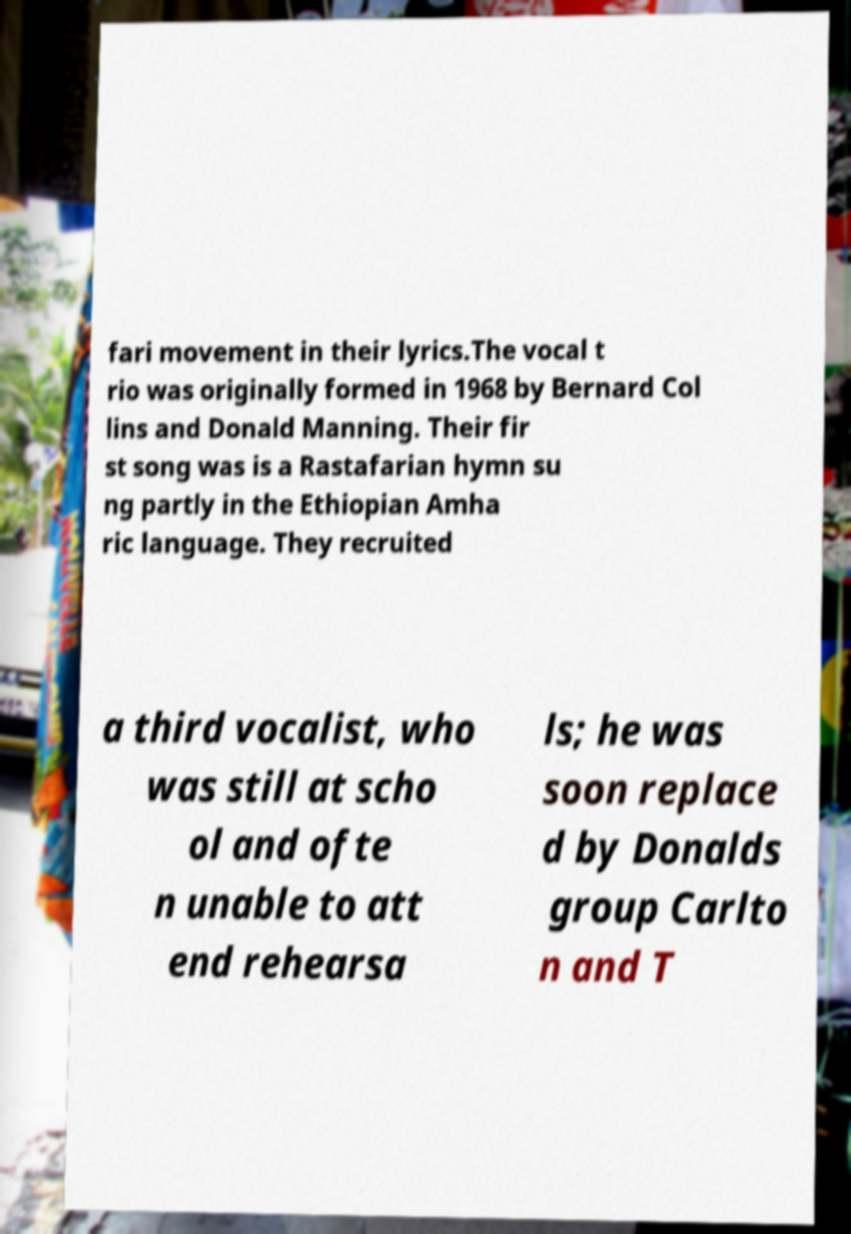I need the written content from this picture converted into text. Can you do that? fari movement in their lyrics.The vocal t rio was originally formed in 1968 by Bernard Col lins and Donald Manning. Their fir st song was is a Rastafarian hymn su ng partly in the Ethiopian Amha ric language. They recruited a third vocalist, who was still at scho ol and ofte n unable to att end rehearsa ls; he was soon replace d by Donalds group Carlto n and T 